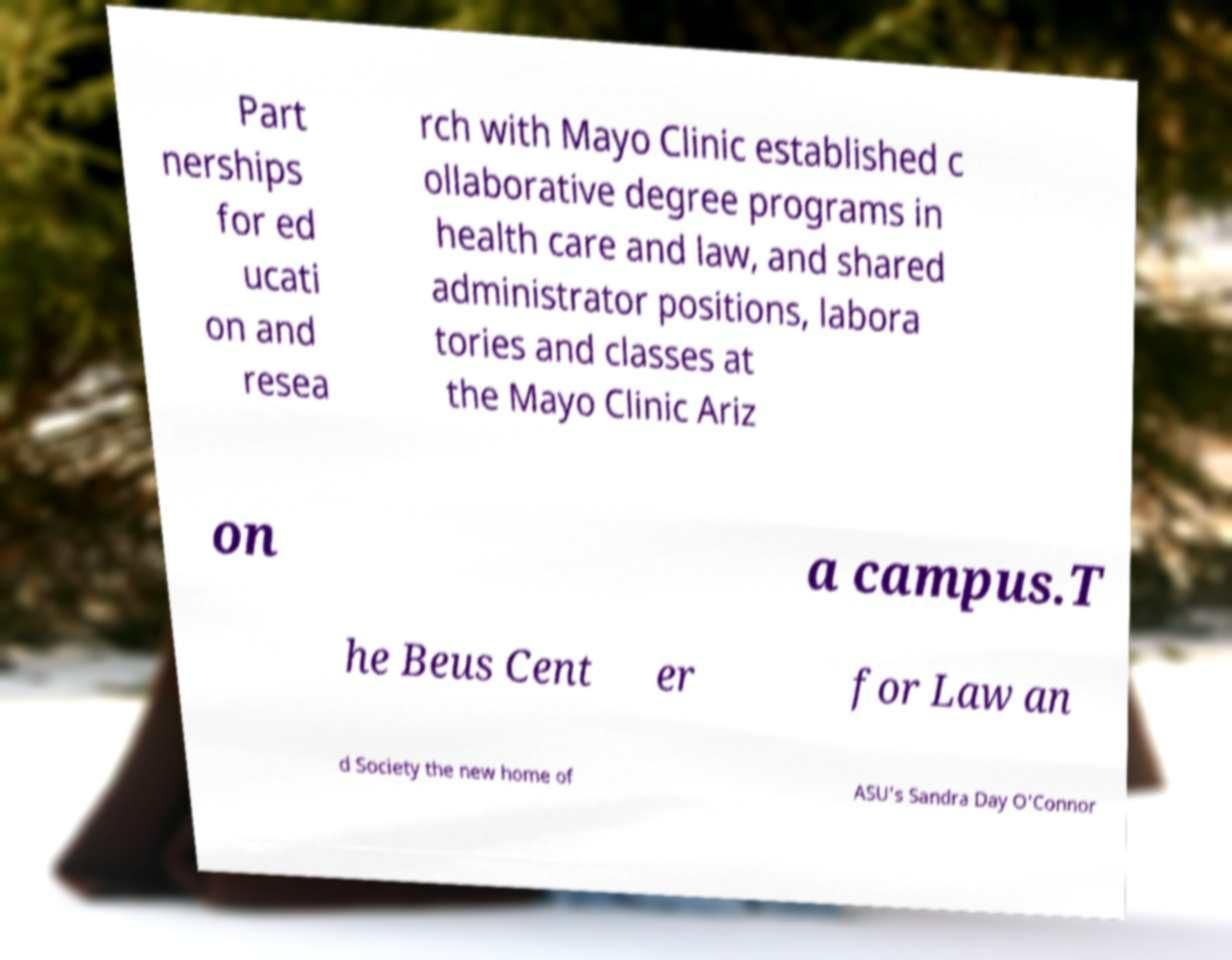Please read and relay the text visible in this image. What does it say? Part nerships for ed ucati on and resea rch with Mayo Clinic established c ollaborative degree programs in health care and law, and shared administrator positions, labora tories and classes at the Mayo Clinic Ariz on a campus.T he Beus Cent er for Law an d Society the new home of ASU's Sandra Day O'Connor 